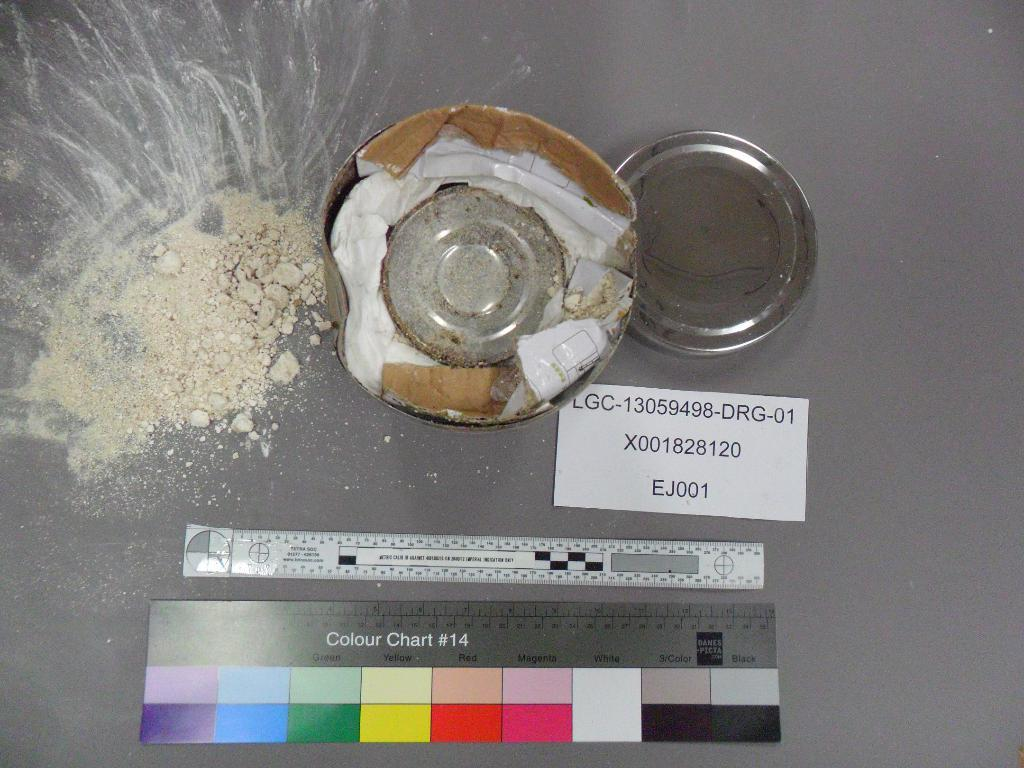<image>
Summarize the visual content of the image. A white powdery substance that is all over and underneath it is a colour chart with various colors. 